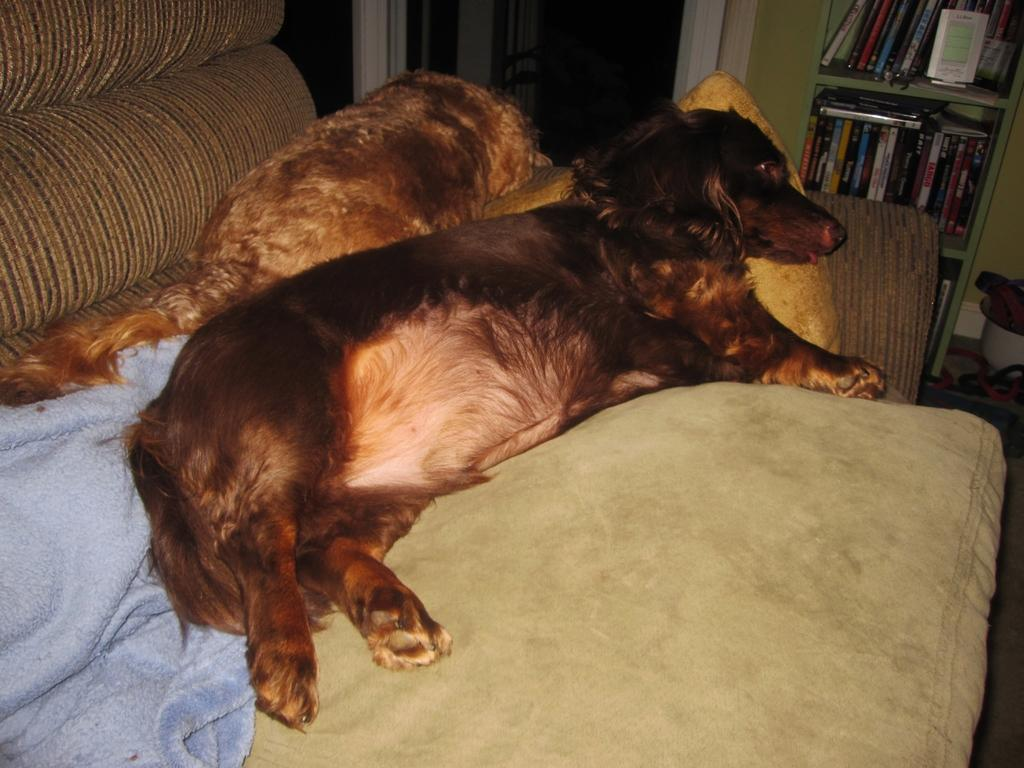What can be seen on the sofa in the image? There are two animals on the sofa. What is covering part of the sofa? There is a towel on the sofa. What is located on the right side of the image? There is a cupboard with books on the right side of the image. What architectural feature is visible in the image? There is a door visible in the image. Where is the bucket located in the image? There is no bucket present in the image. What type of territory is depicted in the image? The image does not depict any specific territory; it features a sofa with animals, a towel, a cupboard with books, and a door. 